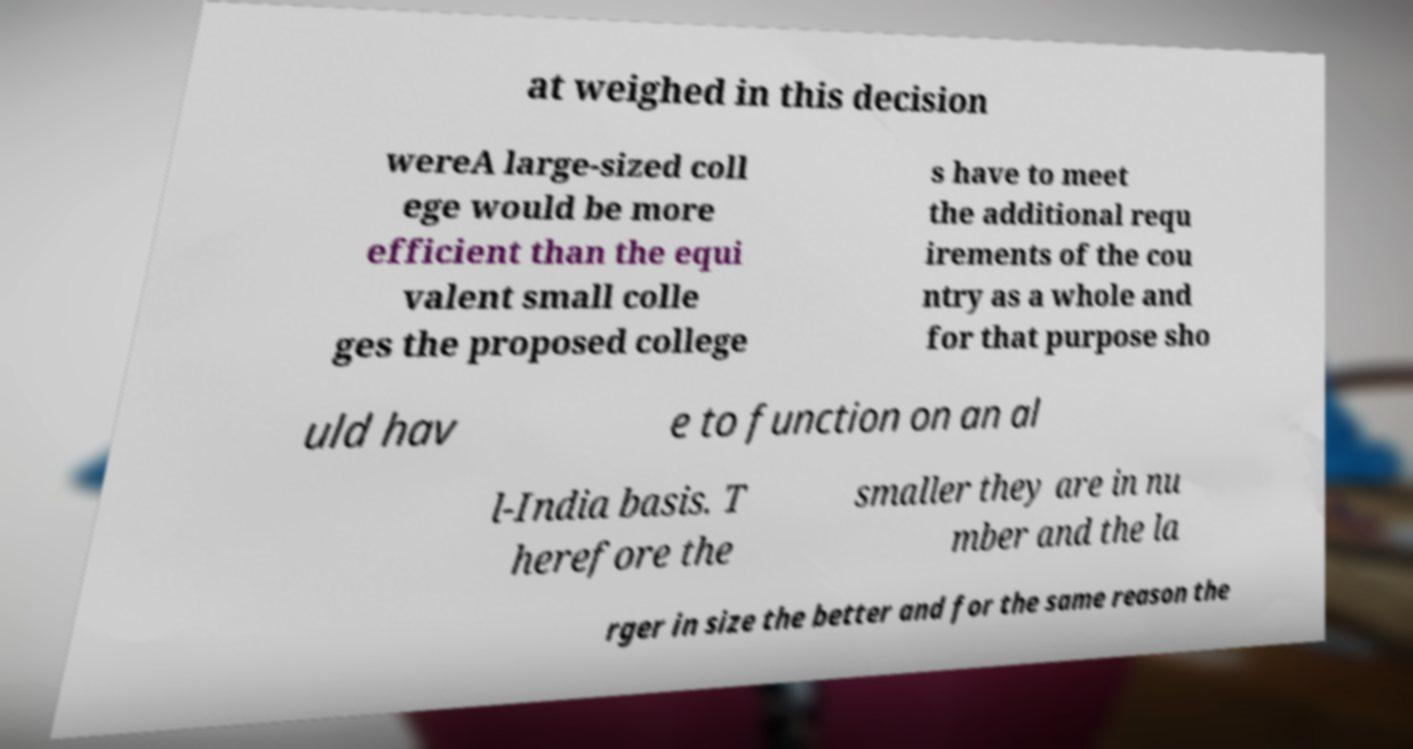I need the written content from this picture converted into text. Can you do that? at weighed in this decision wereA large-sized coll ege would be more efficient than the equi valent small colle ges the proposed college s have to meet the additional requ irements of the cou ntry as a whole and for that purpose sho uld hav e to function on an al l-India basis. T herefore the smaller they are in nu mber and the la rger in size the better and for the same reason the 